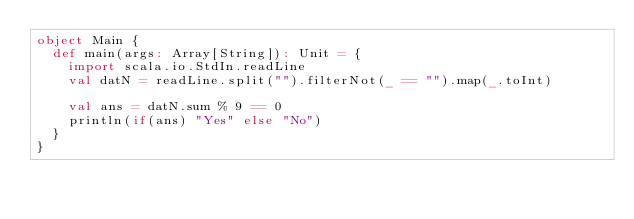<code> <loc_0><loc_0><loc_500><loc_500><_Scala_>object Main {
  def main(args: Array[String]): Unit = {
    import scala.io.StdIn.readLine
    val datN = readLine.split("").filterNot(_ == "").map(_.toInt)

    val ans = datN.sum % 9 == 0
    println(if(ans) "Yes" else "No")
  }
}
</code> 